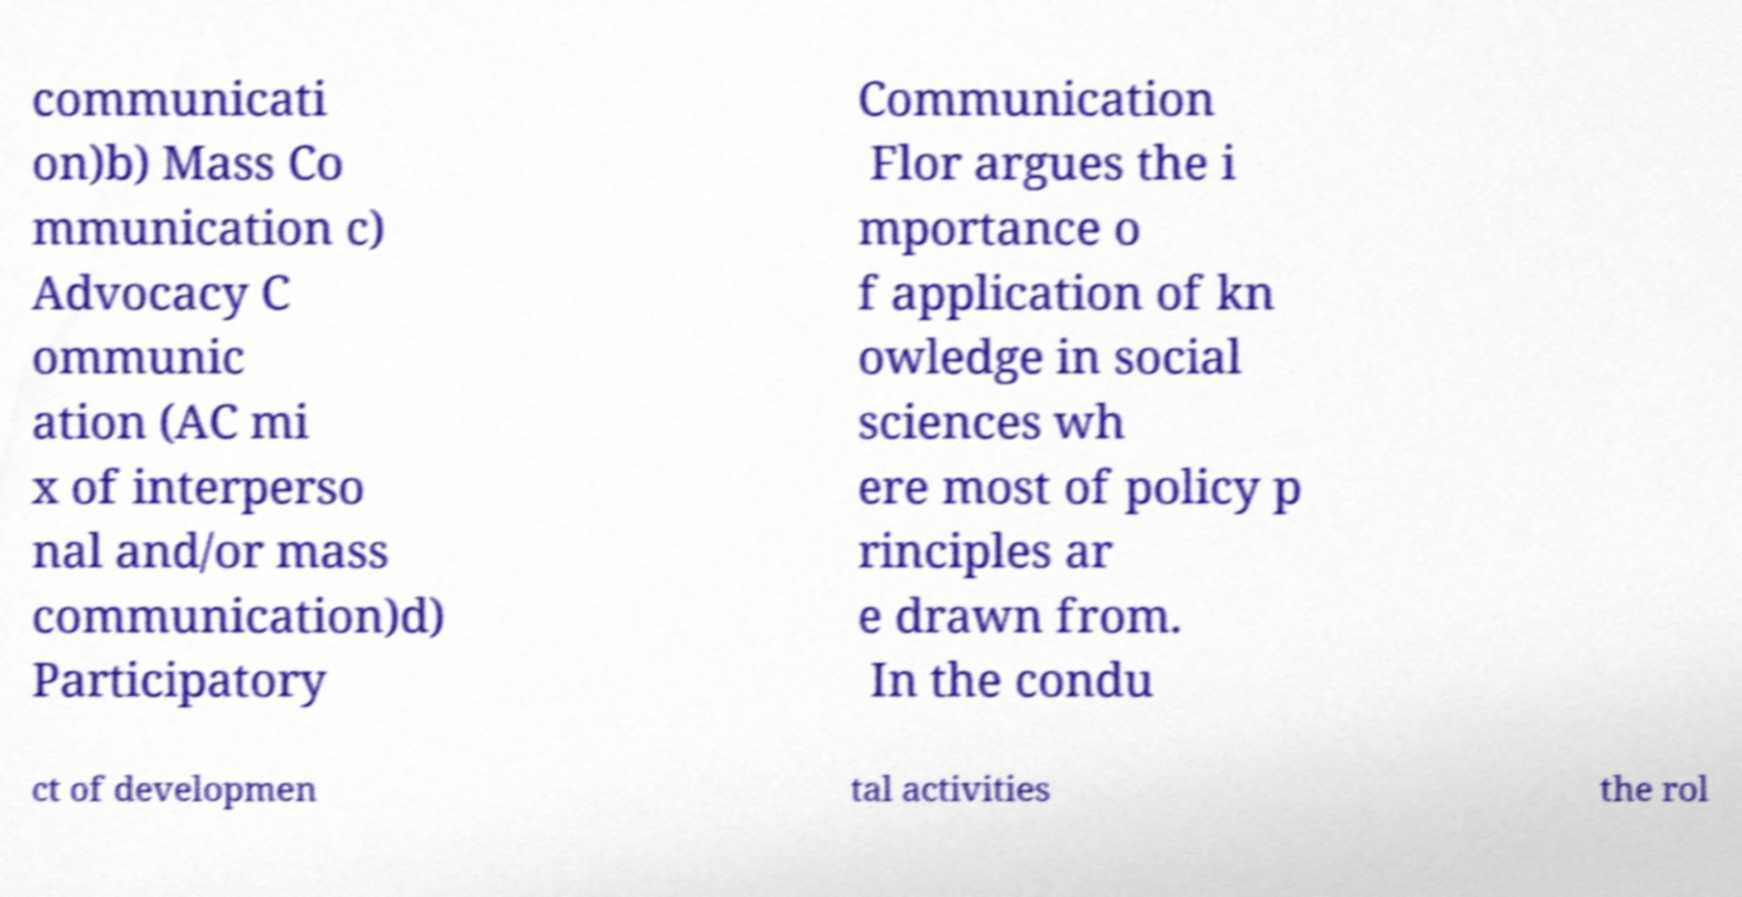Could you extract and type out the text from this image? communicati on)b) Mass Co mmunication c) Advocacy C ommunic ation (AC mi x of interperso nal and/or mass communication)d) Participatory Communication Flor argues the i mportance o f application of kn owledge in social sciences wh ere most of policy p rinciples ar e drawn from. In the condu ct of developmen tal activities the rol 